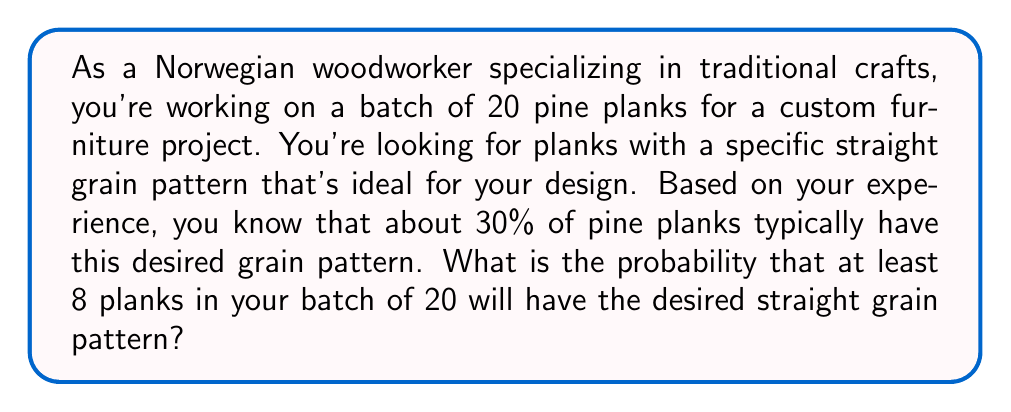Show me your answer to this math problem. To solve this problem, we'll use the binomial probability distribution, as we're dealing with a fixed number of independent trials (20 planks) with a constant probability of success (30% for desired grain pattern).

Let $X$ be the number of planks with the desired grain pattern.
$n = 20$ (total number of planks)
$p = 0.30$ (probability of a plank having the desired pattern)

We want to find $P(X \geq 8)$, which is equivalent to $1 - P(X \leq 7)$

Using the cumulative binomial probability formula:

$$P(X \leq k) = \sum_{i=0}^k \binom{n}{i} p^i (1-p)^{n-i}$$

We need to calculate:

$$1 - P(X \leq 7) = 1 - \sum_{i=0}^7 \binom{20}{i} (0.30)^i (0.70)^{20-i}$$

Using a calculator or computer to evaluate this sum:

$$1 - (0.0416 + 0.1780 + 0.3560 + 0.4258 + 0.3345 + 0.1788 + 0.0638 + 0.0156)$$
$$= 1 - 0.5941$$
$$= 0.4059$$
Answer: The probability of having at least 8 planks with the desired straight grain pattern in a batch of 20 pine planks is approximately 0.4059 or 40.59%. 